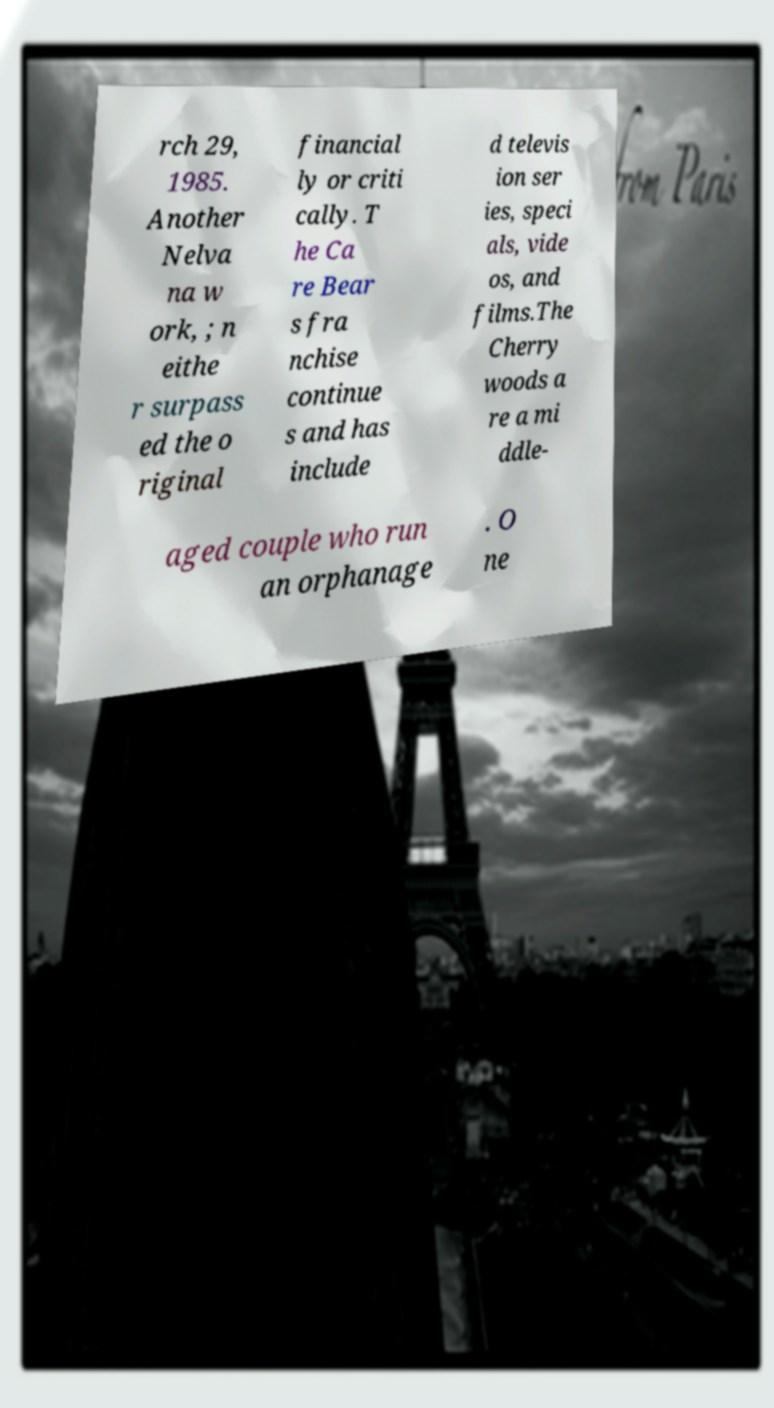Could you assist in decoding the text presented in this image and type it out clearly? rch 29, 1985. Another Nelva na w ork, ; n eithe r surpass ed the o riginal financial ly or criti cally. T he Ca re Bear s fra nchise continue s and has include d televis ion ser ies, speci als, vide os, and films.The Cherry woods a re a mi ddle- aged couple who run an orphanage . O ne 